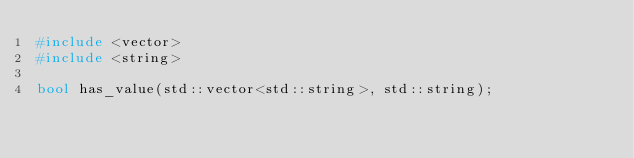<code> <loc_0><loc_0><loc_500><loc_500><_C++_>#include <vector>
#include <string>

bool has_value(std::vector<std::string>, std::string);</code> 